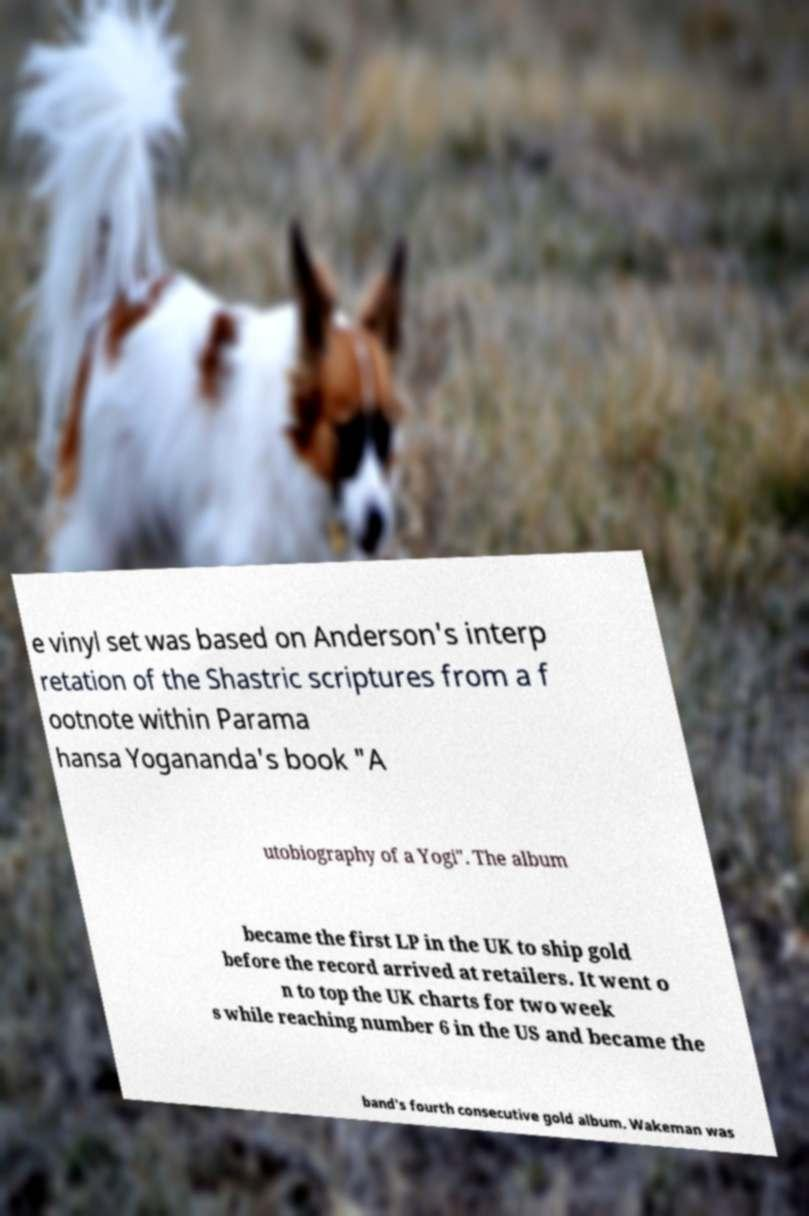Please identify and transcribe the text found in this image. e vinyl set was based on Anderson's interp retation of the Shastric scriptures from a f ootnote within Parama hansa Yogananda's book "A utobiography of a Yogi". The album became the first LP in the UK to ship gold before the record arrived at retailers. It went o n to top the UK charts for two week s while reaching number 6 in the US and became the band's fourth consecutive gold album. Wakeman was 